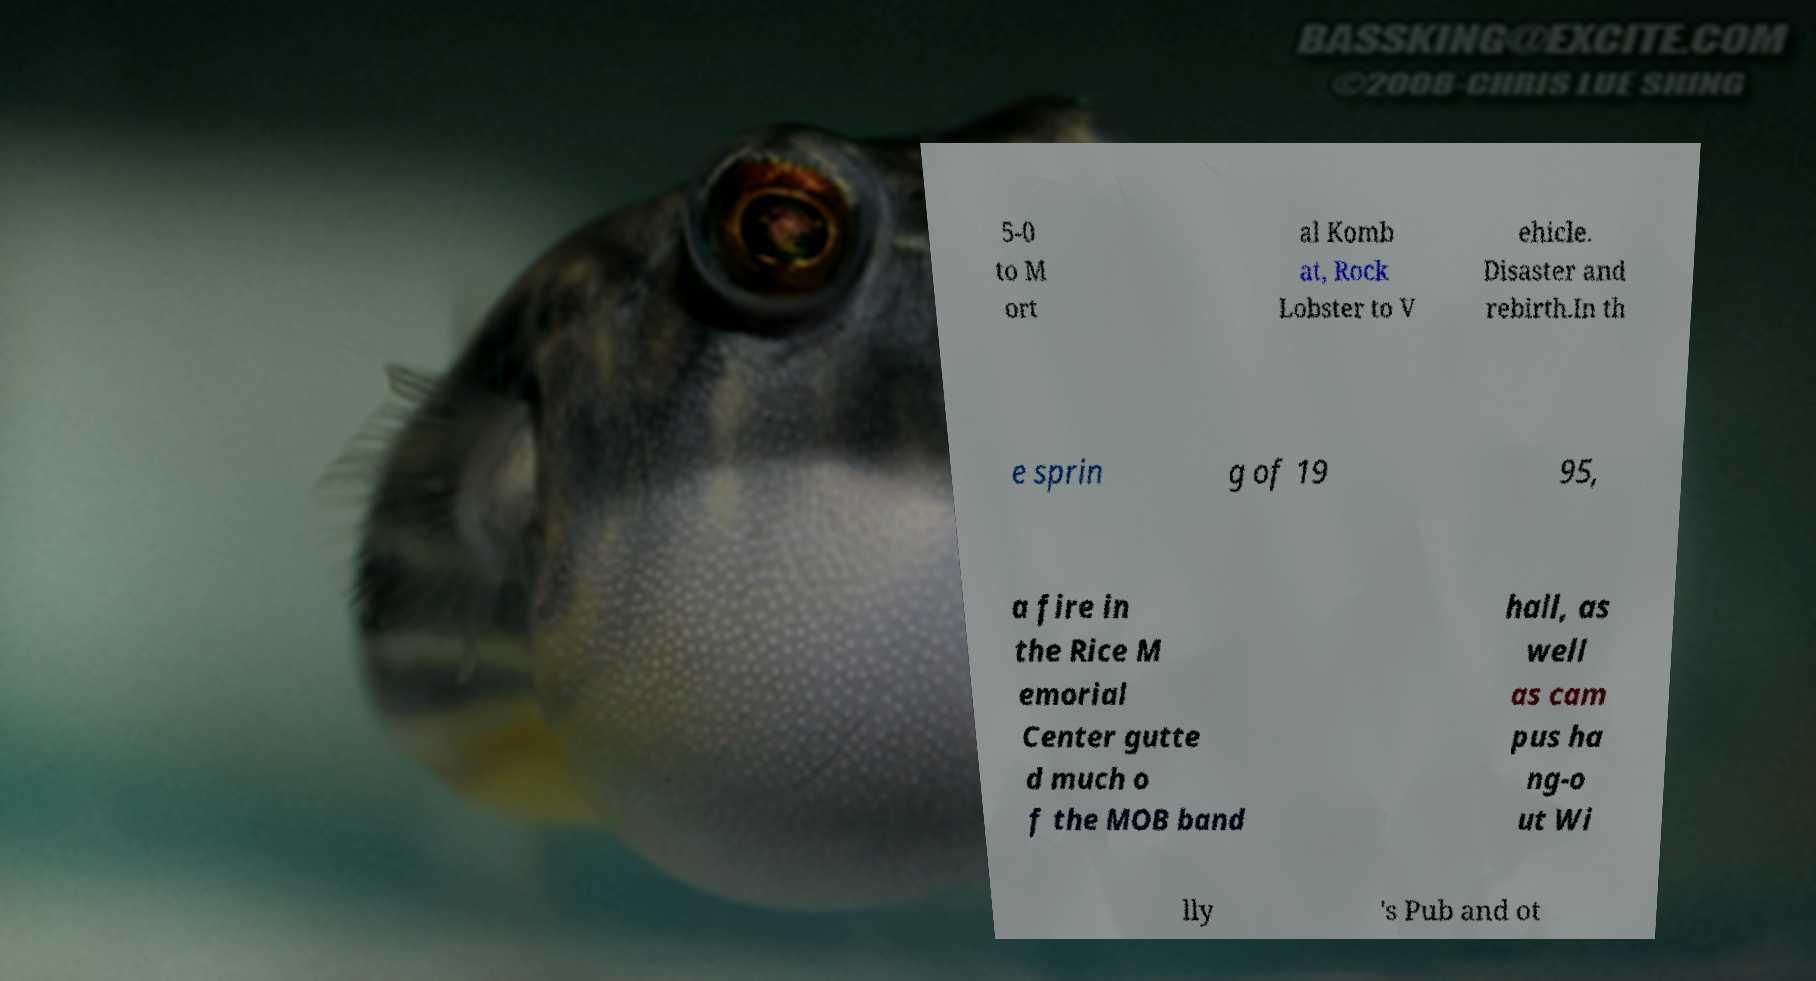Could you assist in decoding the text presented in this image and type it out clearly? 5-0 to M ort al Komb at, Rock Lobster to V ehicle. Disaster and rebirth.In th e sprin g of 19 95, a fire in the Rice M emorial Center gutte d much o f the MOB band hall, as well as cam pus ha ng-o ut Wi lly 's Pub and ot 